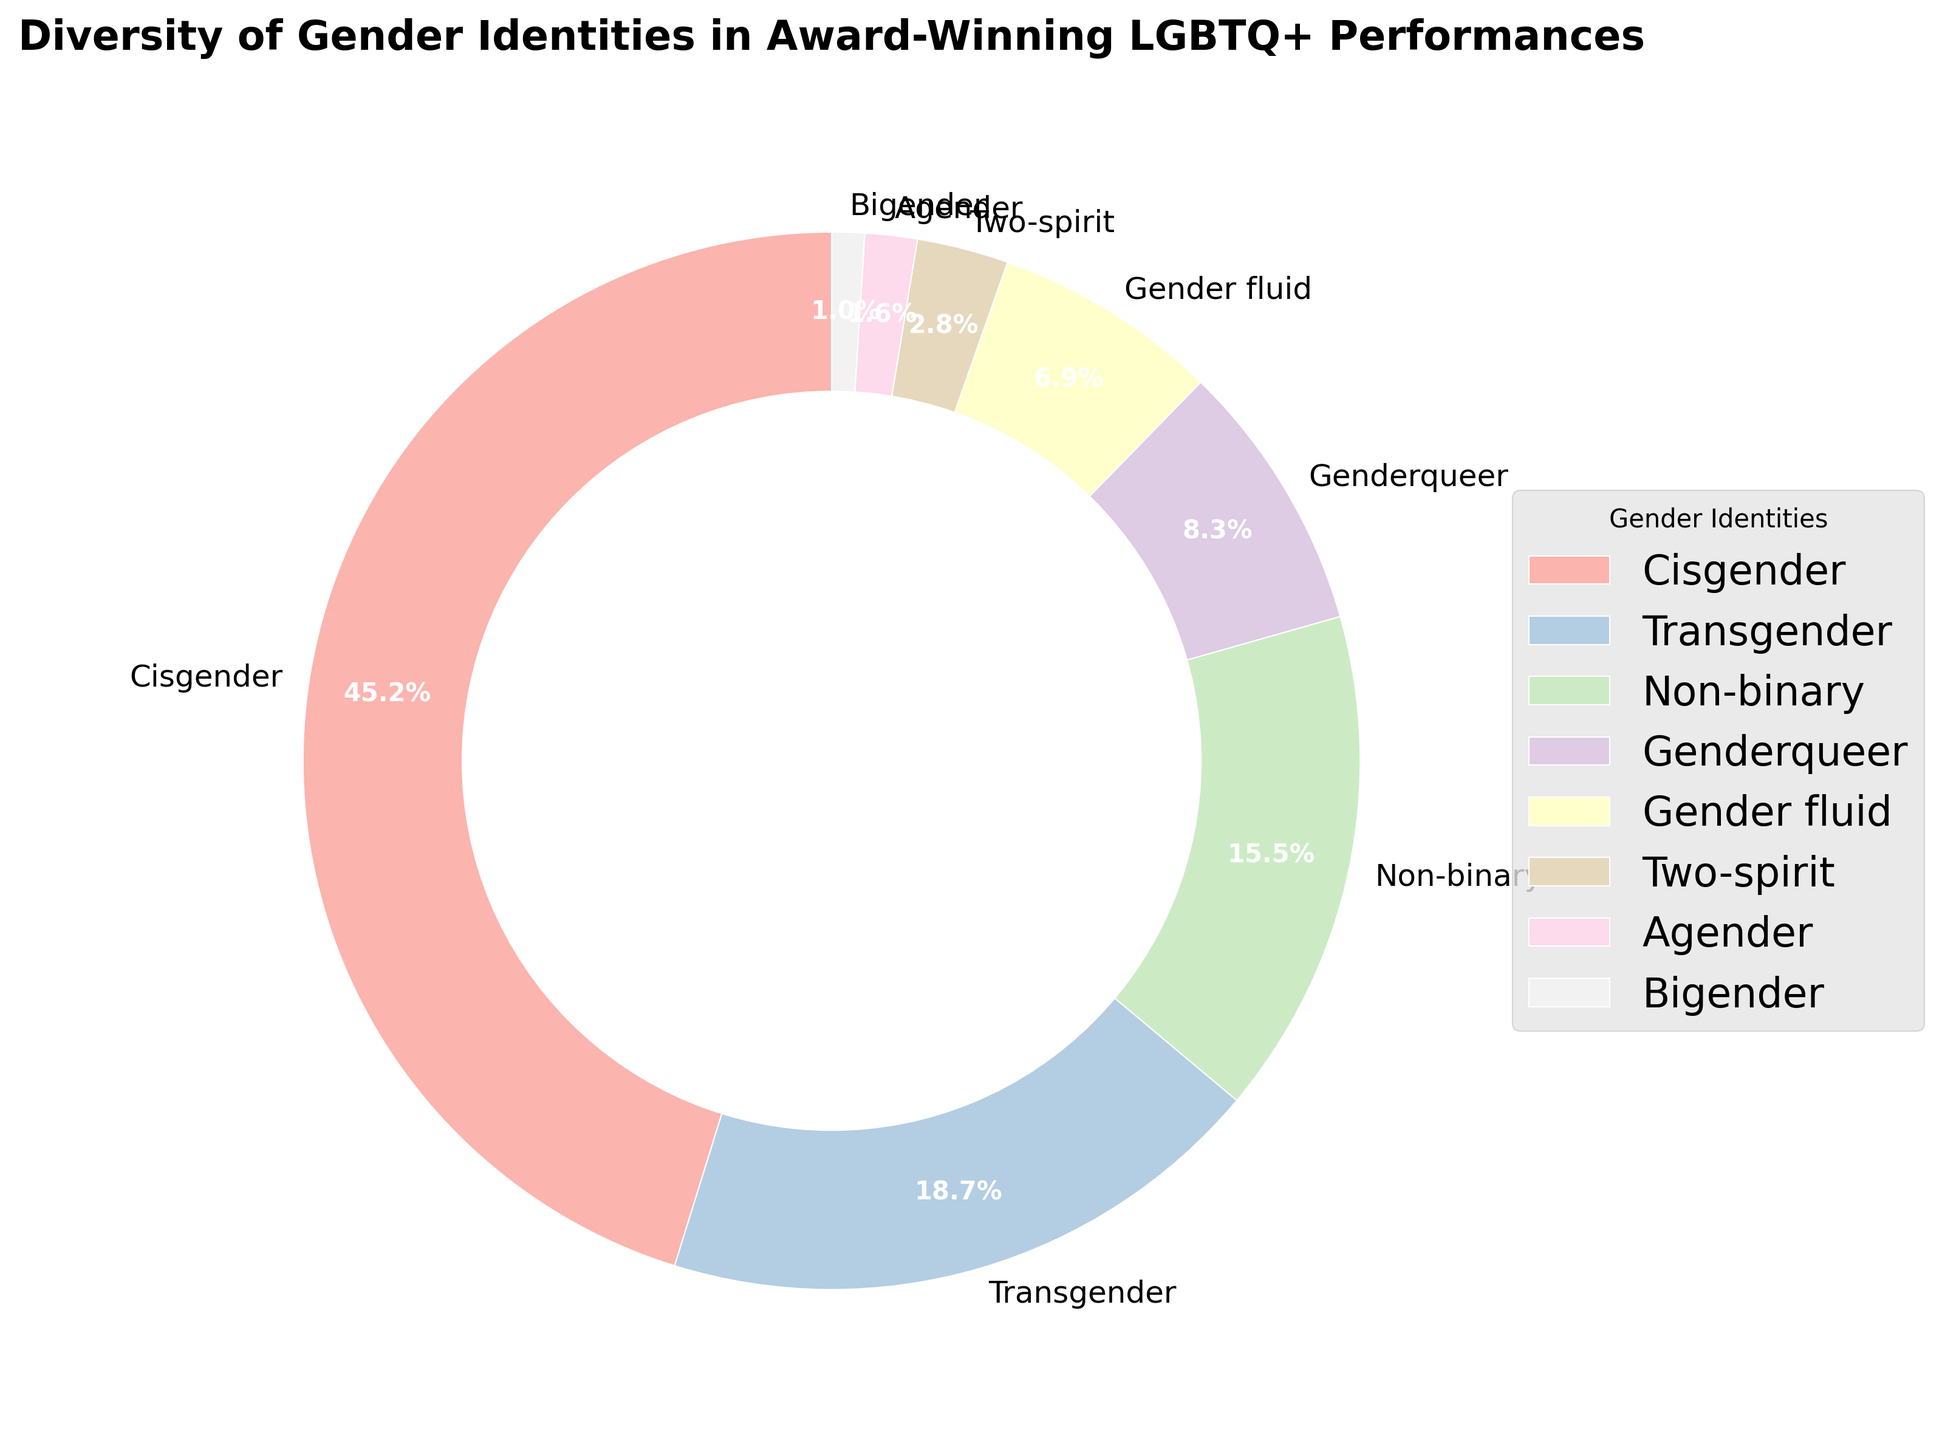Which gender identity has the highest representation percentage? The pie chart can be directly referenced to find the largest wedge, which indicates the highest representation percentage. The label text on this wedge shows "Cisgender" with a percentage value of 45.2%.
Answer: Cisgender What's the combined percentage representation of Genderqueer and Gender fluid identities? First, identify the percentages for Genderqueer (8.3%) and Gender fluid (6.9%) on the pie chart. Then sum these values: 8.3% + 6.9% = 15.2%.
Answer: 15.2% Which gender identity has the lowest representation in award-winning LGBTQ+ performances? Locate the smallest wedge in the pie chart, which corresponds to the lowest percentage. This wedge is labeled "Bigender" with a percentage value of 1.0%.
Answer: Bigender Is the percentage of Non-binary identities greater than the sum of Two-spirit and Agender identities? Identify the percentages: Non-binary (15.5%), Two-spirit (2.8%), Agender (1.6%). Calculate the sum of Two-spirit and Agender: 2.8% + 1.6% = 4.4%. Compare 15.5% (Non-binary) with 4.4%. 15.5% > 4.4%, so the answer is yes.
Answer: Yes If the sum of Transgender, Non-binary, and Genderqueer is represented as X, what is X? Identify the percentages: Transgender (18.7%), Non-binary (15.5%), Genderqueer (8.3%). Sum these percentages: 18.7% + 15.5% + 8.3% = 42.5%.
Answer: 42.5% Comparing Agender identities with Gender fluid identities, which one has a higher representation and by how much? Identify the percentages: Agender (1.6%) and Gender fluid (6.9%). Subtract the smaller value from the larger: 6.9% - 1.6% = 5.3%. Gender fluid has a higher representation by 5.3%.
Answer: Gender fluid, by 5.3% What is the total percentage of all identities represented in the chart? The total percentage of a pie chart is always 100%, as it represents the whole dataset divided into parts.
Answer: 100% Which gender identities have a representation percentage greater than 10%? Identify the wedges with percentages greater than 10%: Cisgender (45.2%), Transgender (18.7%), Non-binary (15.5%).
Answer: Cisgender, Transgender, Non-binary What is the difference in percentage between the highest and lowest represented gender identities? Identify the highest percentage: Cisgender (45.2%). Identify the lowest percentage: Bigender (1.0%). Subtract the smallest percentage from the largest: 45.2% - 1.0% = 44.2%.
Answer: 44.2% Are the combined percentages of Two-spirit and Bigender greater or less than Genderqueer? Identify the percentages: Two-spirit (2.8%), Bigender (1.0%), Genderqueer (8.3%). Sum Two-spirit and Bigender: 2.8% + 1.0% = 3.8%. Compare with Genderqueer (8.3%). 3.8% < 8.3%, so the combined percentage is less.
Answer: Less 